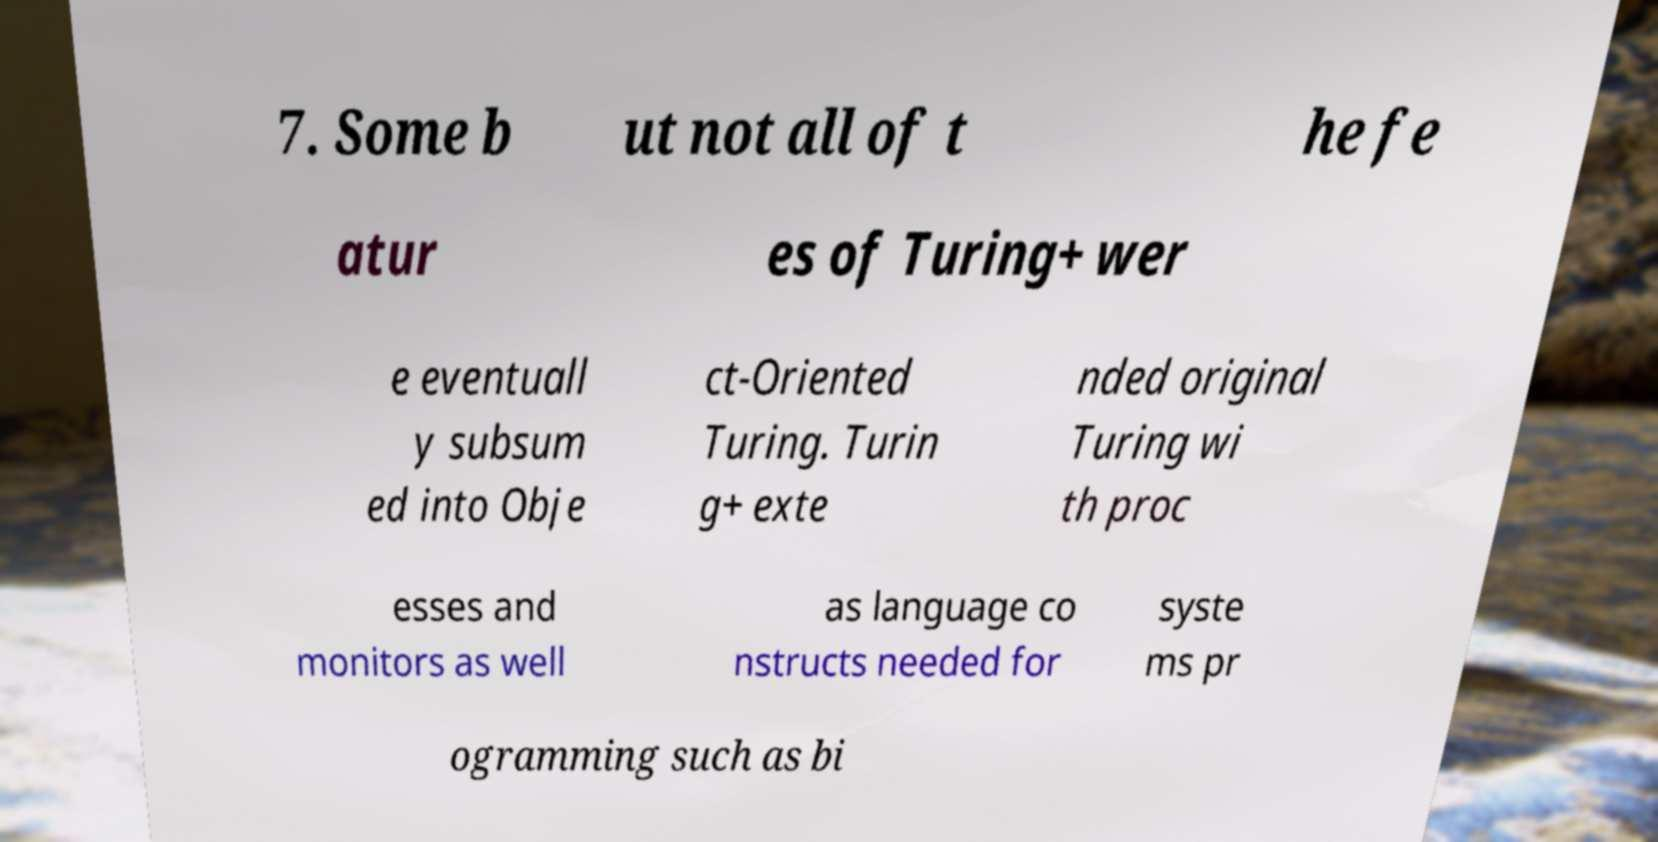Could you assist in decoding the text presented in this image and type it out clearly? 7. Some b ut not all of t he fe atur es of Turing+ wer e eventuall y subsum ed into Obje ct-Oriented Turing. Turin g+ exte nded original Turing wi th proc esses and monitors as well as language co nstructs needed for syste ms pr ogramming such as bi 